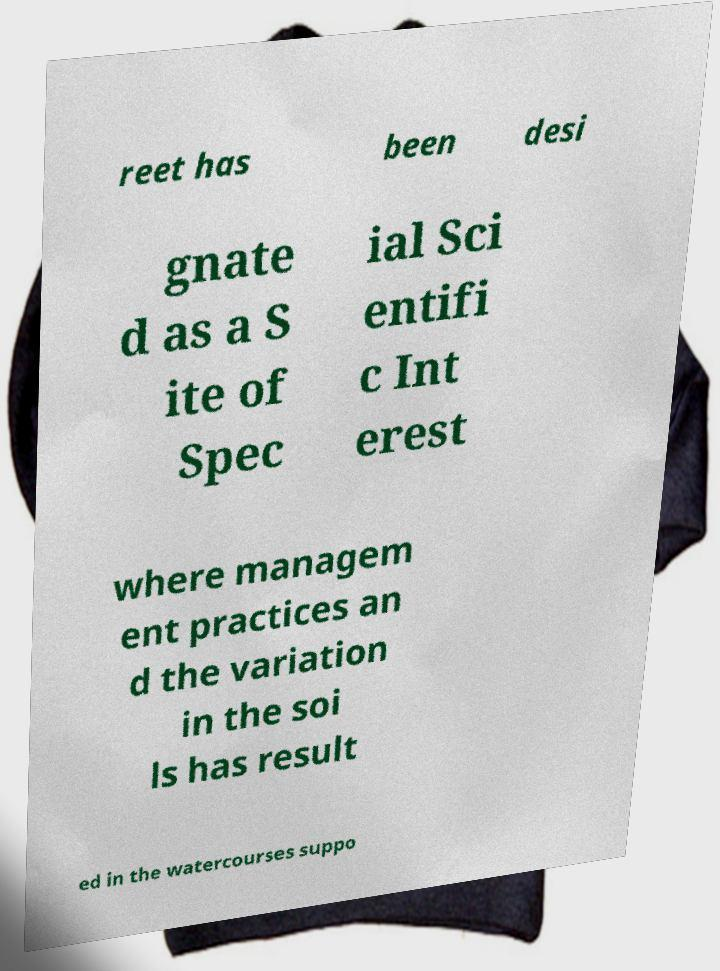Can you accurately transcribe the text from the provided image for me? reet has been desi gnate d as a S ite of Spec ial Sci entifi c Int erest where managem ent practices an d the variation in the soi ls has result ed in the watercourses suppo 